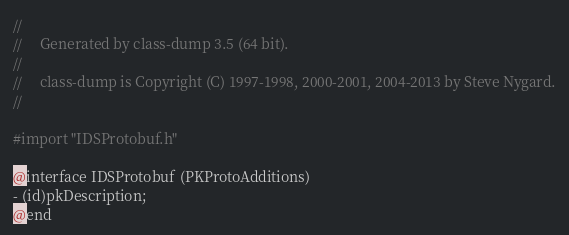Convert code to text. <code><loc_0><loc_0><loc_500><loc_500><_C_>//
//     Generated by class-dump 3.5 (64 bit).
//
//     class-dump is Copyright (C) 1997-1998, 2000-2001, 2004-2013 by Steve Nygard.
//

#import "IDSProtobuf.h"

@interface IDSProtobuf (PKProtoAdditions)
- (id)pkDescription;
@end

</code> 